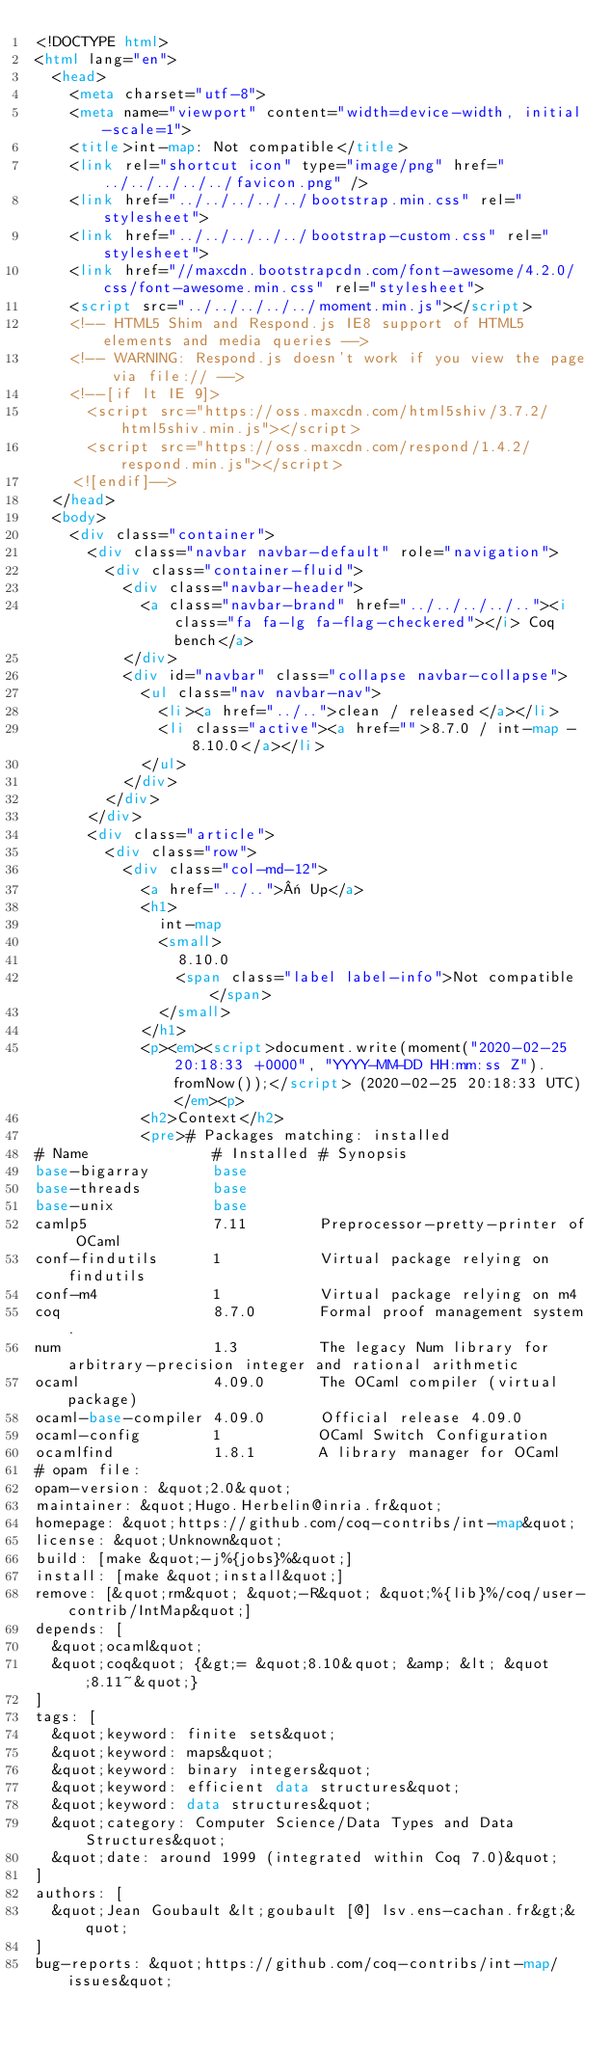<code> <loc_0><loc_0><loc_500><loc_500><_HTML_><!DOCTYPE html>
<html lang="en">
  <head>
    <meta charset="utf-8">
    <meta name="viewport" content="width=device-width, initial-scale=1">
    <title>int-map: Not compatible</title>
    <link rel="shortcut icon" type="image/png" href="../../../../../favicon.png" />
    <link href="../../../../../bootstrap.min.css" rel="stylesheet">
    <link href="../../../../../bootstrap-custom.css" rel="stylesheet">
    <link href="//maxcdn.bootstrapcdn.com/font-awesome/4.2.0/css/font-awesome.min.css" rel="stylesheet">
    <script src="../../../../../moment.min.js"></script>
    <!-- HTML5 Shim and Respond.js IE8 support of HTML5 elements and media queries -->
    <!-- WARNING: Respond.js doesn't work if you view the page via file:// -->
    <!--[if lt IE 9]>
      <script src="https://oss.maxcdn.com/html5shiv/3.7.2/html5shiv.min.js"></script>
      <script src="https://oss.maxcdn.com/respond/1.4.2/respond.min.js"></script>
    <![endif]-->
  </head>
  <body>
    <div class="container">
      <div class="navbar navbar-default" role="navigation">
        <div class="container-fluid">
          <div class="navbar-header">
            <a class="navbar-brand" href="../../../../.."><i class="fa fa-lg fa-flag-checkered"></i> Coq bench</a>
          </div>
          <div id="navbar" class="collapse navbar-collapse">
            <ul class="nav navbar-nav">
              <li><a href="../..">clean / released</a></li>
              <li class="active"><a href="">8.7.0 / int-map - 8.10.0</a></li>
            </ul>
          </div>
        </div>
      </div>
      <div class="article">
        <div class="row">
          <div class="col-md-12">
            <a href="../..">« Up</a>
            <h1>
              int-map
              <small>
                8.10.0
                <span class="label label-info">Not compatible</span>
              </small>
            </h1>
            <p><em><script>document.write(moment("2020-02-25 20:18:33 +0000", "YYYY-MM-DD HH:mm:ss Z").fromNow());</script> (2020-02-25 20:18:33 UTC)</em><p>
            <h2>Context</h2>
            <pre># Packages matching: installed
# Name              # Installed # Synopsis
base-bigarray       base
base-threads        base
base-unix           base
camlp5              7.11        Preprocessor-pretty-printer of OCaml
conf-findutils      1           Virtual package relying on findutils
conf-m4             1           Virtual package relying on m4
coq                 8.7.0       Formal proof management system.
num                 1.3         The legacy Num library for arbitrary-precision integer and rational arithmetic
ocaml               4.09.0      The OCaml compiler (virtual package)
ocaml-base-compiler 4.09.0      Official release 4.09.0
ocaml-config        1           OCaml Switch Configuration
ocamlfind           1.8.1       A library manager for OCaml
# opam file:
opam-version: &quot;2.0&quot;
maintainer: &quot;Hugo.Herbelin@inria.fr&quot;
homepage: &quot;https://github.com/coq-contribs/int-map&quot;
license: &quot;Unknown&quot;
build: [make &quot;-j%{jobs}%&quot;]
install: [make &quot;install&quot;]
remove: [&quot;rm&quot; &quot;-R&quot; &quot;%{lib}%/coq/user-contrib/IntMap&quot;]
depends: [
  &quot;ocaml&quot;
  &quot;coq&quot; {&gt;= &quot;8.10&quot; &amp; &lt; &quot;8.11~&quot;}
]
tags: [
  &quot;keyword: finite sets&quot;
  &quot;keyword: maps&quot;
  &quot;keyword: binary integers&quot;
  &quot;keyword: efficient data structures&quot;
  &quot;keyword: data structures&quot;
  &quot;category: Computer Science/Data Types and Data Structures&quot;
  &quot;date: around 1999 (integrated within Coq 7.0)&quot;
]
authors: [
  &quot;Jean Goubault &lt;goubault [@] lsv.ens-cachan.fr&gt;&quot;
]
bug-reports: &quot;https://github.com/coq-contribs/int-map/issues&quot;</code> 